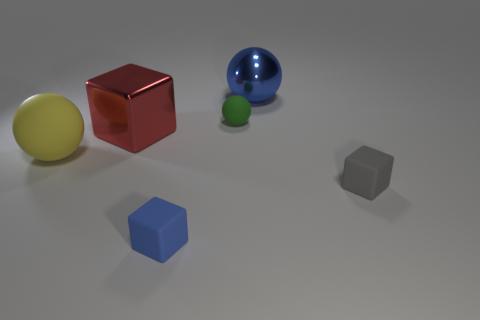What is the material of the blue object that is behind the red cube? metal 